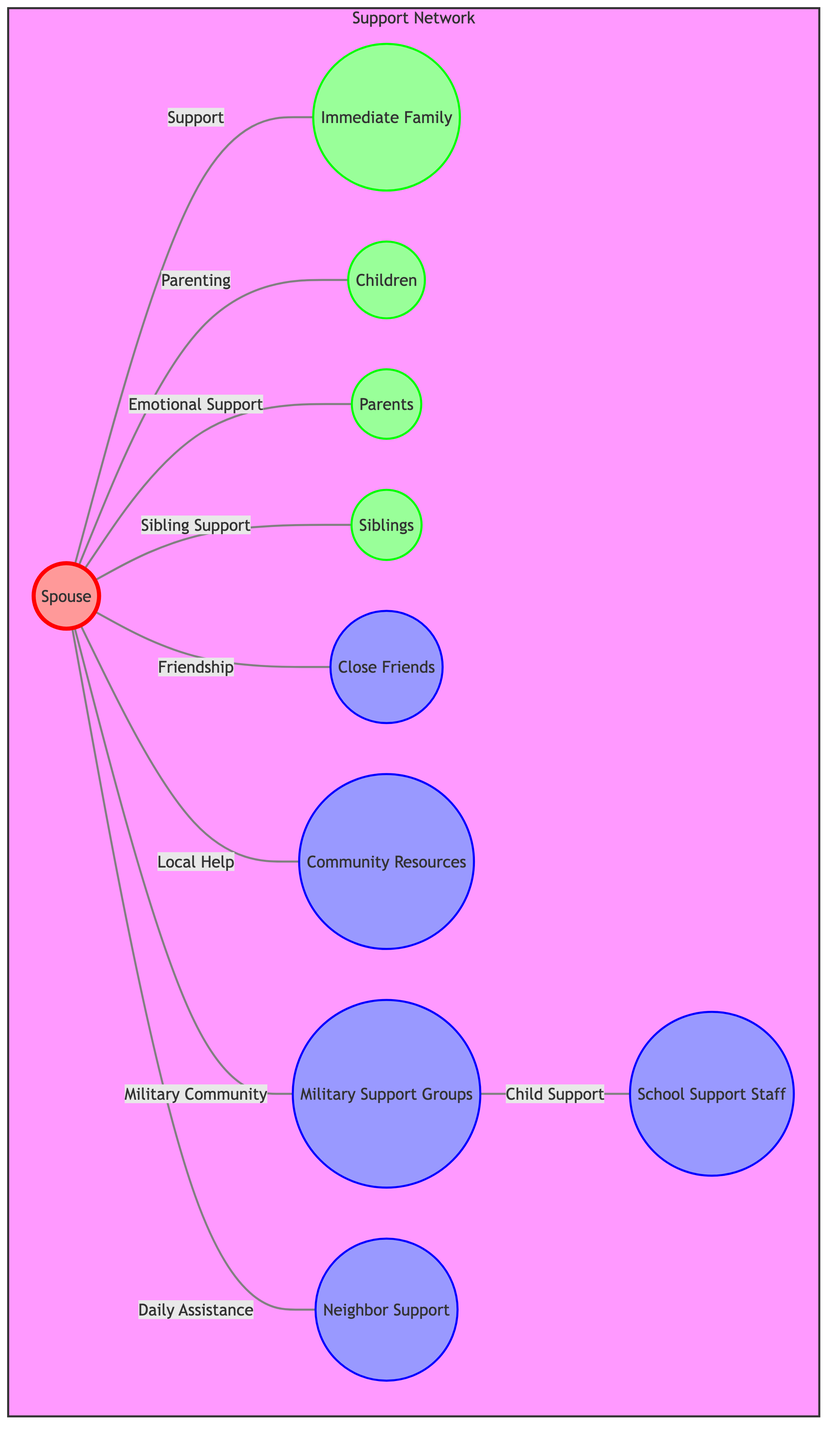What's the total number of nodes in the diagram? The diagram includes the nodes for Spouse, Immediate Family, Children, Parents, Siblings, Close Friends, Community Resources, Military Support Groups, Neighbor Support, and School Support Staff. Counting each of these gives a total of 10 nodes.
Answer: 10 What type of support is given between the Spouse and Immediate Family? In the diagram, the relationship between the Spouse and Immediate Family is labeled as "Support." This describes the nature of their connection.
Answer: Support How many types of community support are identified in the diagram? The diagram identifies various community resources such as Close Friends, Community Resources, Military Support Groups, and Neighbor Support. Counting these, there are four distinct types of community support.
Answer: 4 Which group provides Child Support as per the diagram? According to the diagram, the Military Support Groups provide support for children, as indicated by the labeled connection from Military Support Groups to School Support Staff.
Answer: Military Support Groups What is the role of Parents in the support network? The relationship is labeled as "Emotional Support," indicating that the Parents provide this specific kind of support to the Spouse.
Answer: Emotional Support Which node is directly connected to both Community Resources and Military Support Groups? In the diagram, the Spouse is directly connected to both Community Resources and Military Support Groups, as indicated by the edges leading from Spouse to these two nodes.
Answer: Spouse What is the connection type between Military Support Groups and School Support Staff? The connection type is labeled as "Child Support," demonstrating the role that Military Support Groups play in supporting children through School Support Staff.
Answer: Child Support Which group is associated with Daily Assistance for the Spouse? The Neighbor Support group has a direct connection to the Spouse, indicating this group provides Daily Assistance.
Answer: Neighbor Support How many relationships exist between the Spouse and other nodes in the diagram? Counting all the edges leading from the Spouse to other nodes, there are a total of 8 relationships—one for each connection to Immediate Family, Children, Parents, Siblings, Close Friends, Community Resources, Military Support Groups, and Neighbor Support.
Answer: 8 